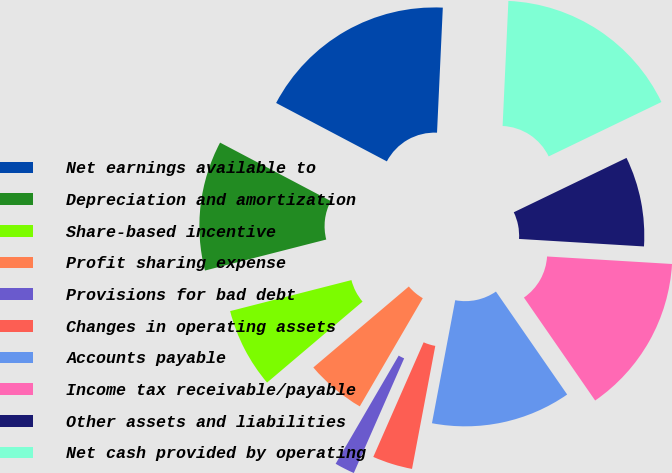Convert chart. <chart><loc_0><loc_0><loc_500><loc_500><pie_chart><fcel>Net earnings available to<fcel>Depreciation and amortization<fcel>Share-based incentive<fcel>Profit sharing expense<fcel>Provisions for bad debt<fcel>Changes in operating assets<fcel>Accounts payable<fcel>Income tax receivable/payable<fcel>Other assets and liabilities<fcel>Net cash provided by operating<nl><fcel>18.01%<fcel>11.71%<fcel>7.21%<fcel>5.41%<fcel>1.81%<fcel>3.61%<fcel>12.61%<fcel>14.41%<fcel>8.11%<fcel>17.11%<nl></chart> 